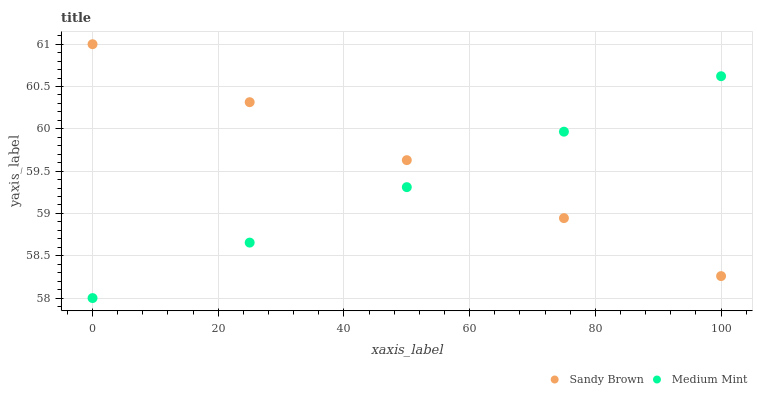Does Medium Mint have the minimum area under the curve?
Answer yes or no. Yes. Does Sandy Brown have the maximum area under the curve?
Answer yes or no. Yes. Does Sandy Brown have the minimum area under the curve?
Answer yes or no. No. Is Medium Mint the smoothest?
Answer yes or no. Yes. Is Sandy Brown the roughest?
Answer yes or no. Yes. Does Medium Mint have the lowest value?
Answer yes or no. Yes. Does Sandy Brown have the lowest value?
Answer yes or no. No. Does Sandy Brown have the highest value?
Answer yes or no. Yes. Does Medium Mint intersect Sandy Brown?
Answer yes or no. Yes. Is Medium Mint less than Sandy Brown?
Answer yes or no. No. Is Medium Mint greater than Sandy Brown?
Answer yes or no. No. 